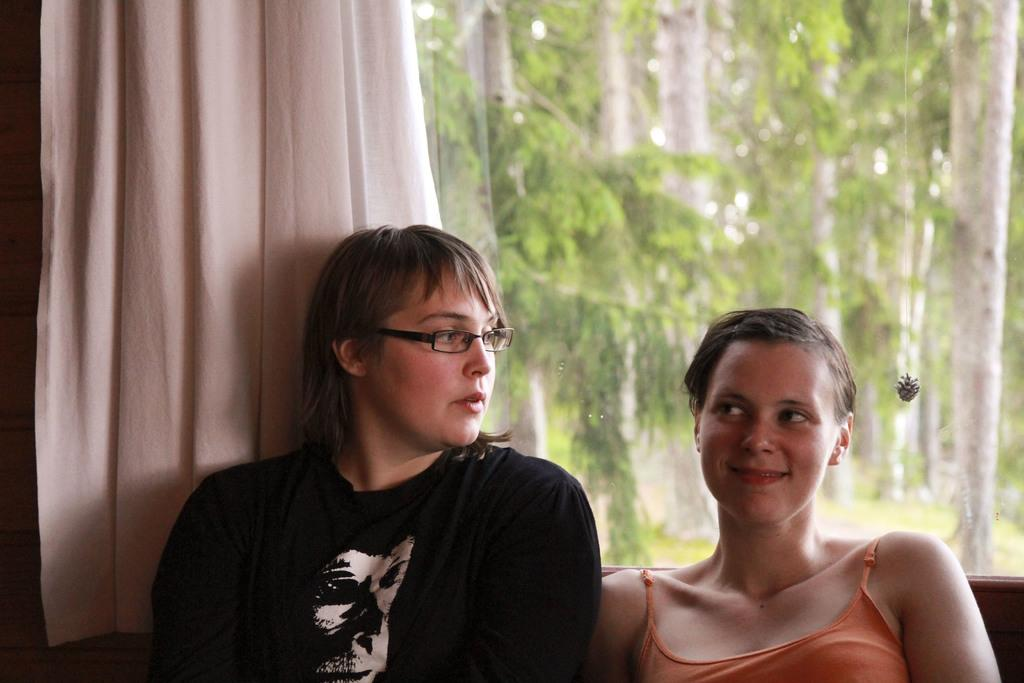How many women are in the image? There are two women in the image. Can you describe the appearance of one of the women? One of the women is wearing spectacles. What is the facial expression of the woman with spectacles? The woman with spectacles is smiling. What can be seen in the background of the image? There is a curtain, a glass object, and trees visible in the background of the image. What type of cream is being used to paint the grape in the image? There is no cream or grape present in the image. 